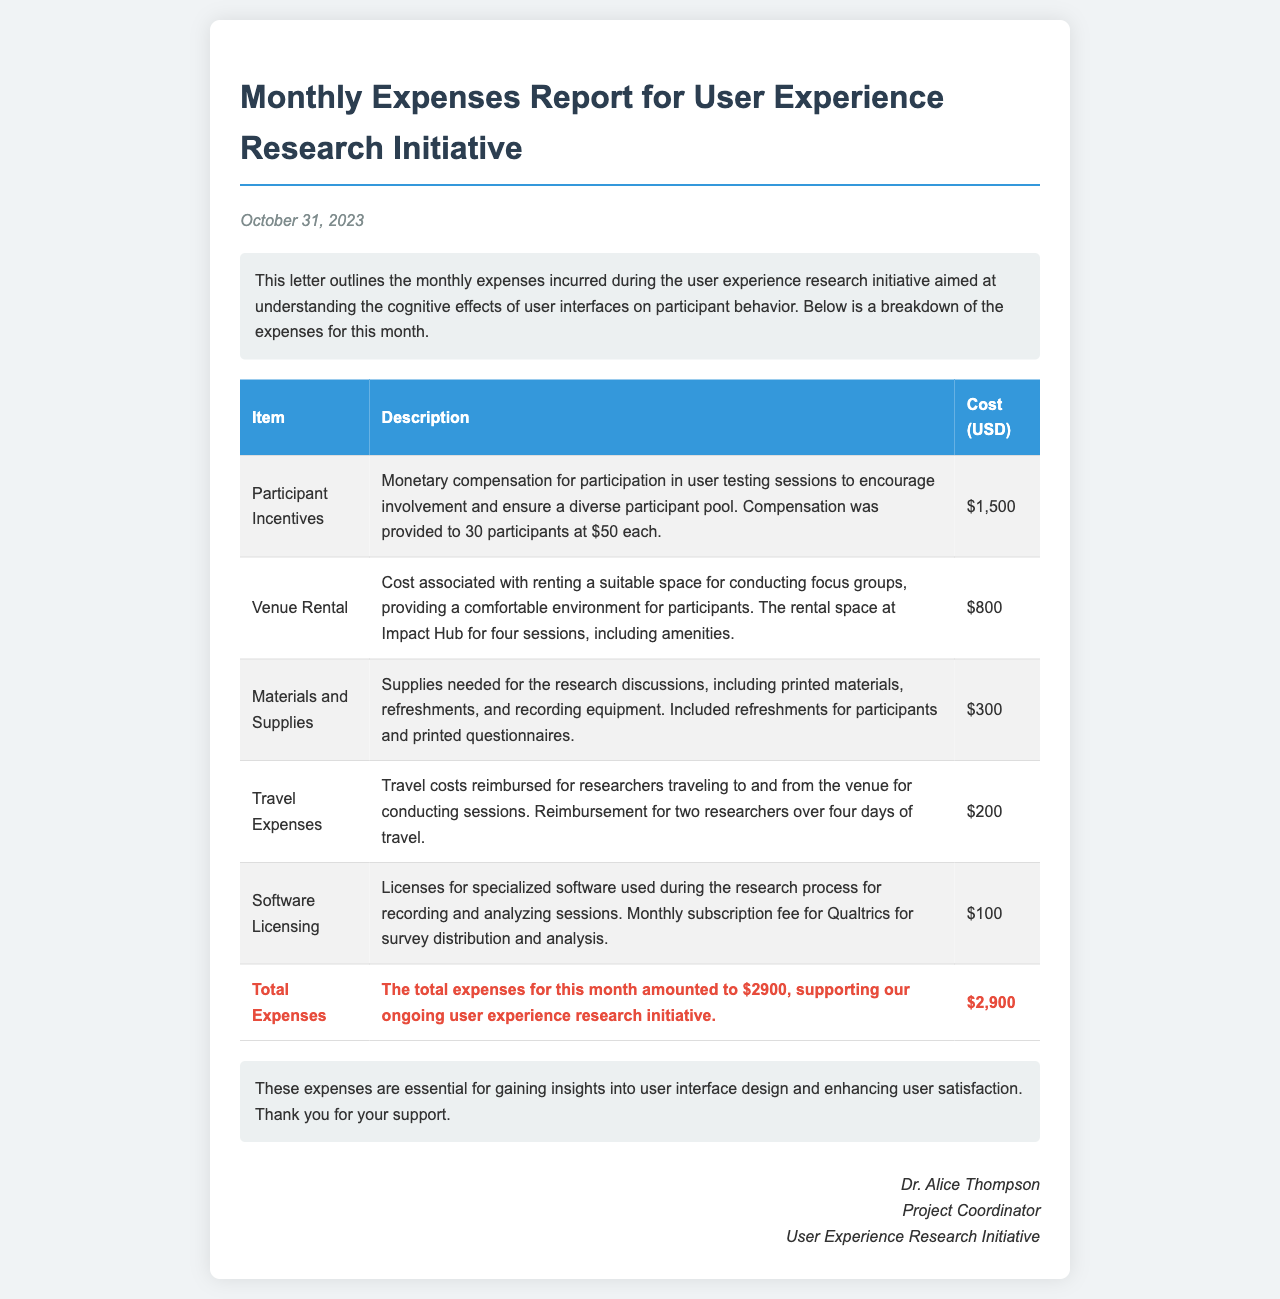What is the date of the report? The date of the report is specified at the top of the letter.
Answer: October 31, 2023 What is the total amount spent on participant incentives? The cost for participant incentives is detailed in the expense table.
Answer: $1,500 How many participants received incentives? The report mentions the number of participants compensated in the section about incentives.
Answer: 30 participants What is the cost of venue rental? The expense for venue rental is listed in the document under venue costs.
Answer: $800 Which software is mentioned for licensing in the report? The type of software used for research is listed in the licensing section.
Answer: Qualtrics What was the total expense for the month? The total expenses for the month are calculated and stated at the end of the expense table.
Answer: $2,900 What are the materials and supplies expenses related to? The materials and supplies costs are described in the corresponding section.
Answer: Research discussions What type of research sessions were conducted? The type of sessions aimed at gathering insights into user interfaces is mentioned in the introductory paragraph.
Answer: Focus groups Who signed the letter? The document specifies the name and title of the person who signed it at the end.
Answer: Dr. Alice Thompson 